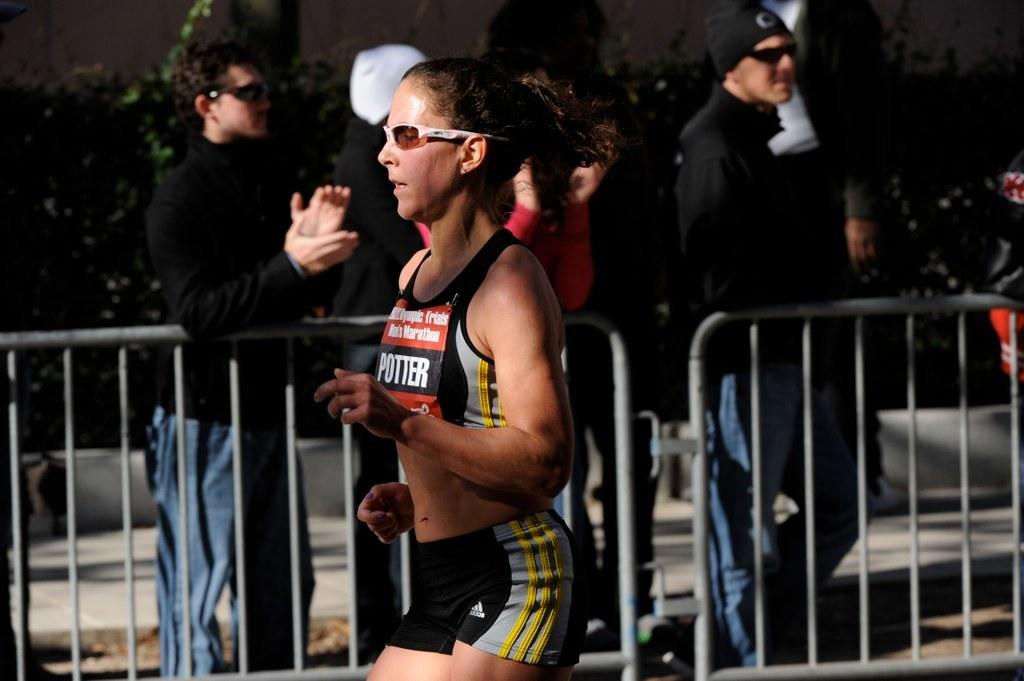<image>
Write a terse but informative summary of the picture. a lady has the name Potter on her shirt 